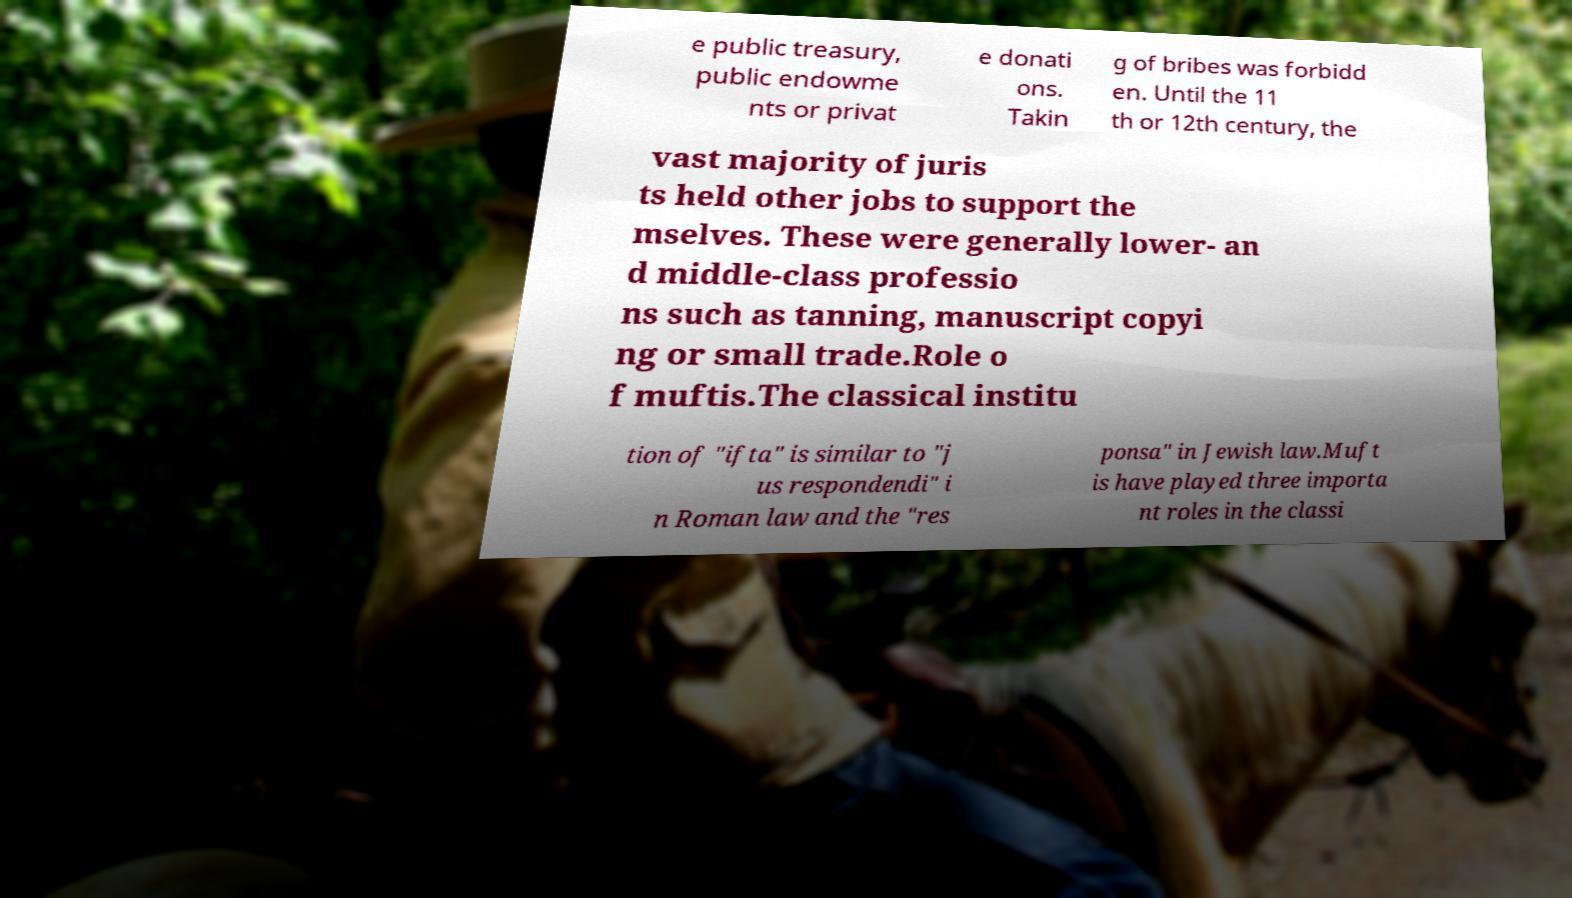Please identify and transcribe the text found in this image. e public treasury, public endowme nts or privat e donati ons. Takin g of bribes was forbidd en. Until the 11 th or 12th century, the vast majority of juris ts held other jobs to support the mselves. These were generally lower- an d middle-class professio ns such as tanning, manuscript copyi ng or small trade.Role o f muftis.The classical institu tion of "ifta" is similar to "j us respondendi" i n Roman law and the "res ponsa" in Jewish law.Muft is have played three importa nt roles in the classi 